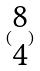Convert formula to latex. <formula><loc_0><loc_0><loc_500><loc_500>( \begin{matrix} 8 \\ 4 \end{matrix} )</formula> 